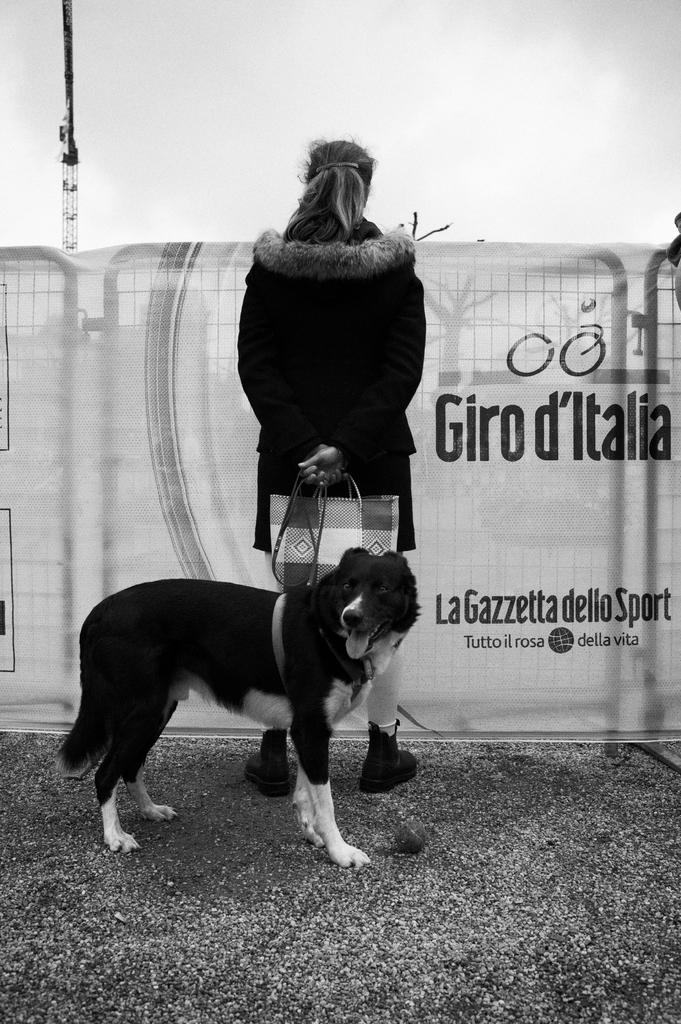Who or what can be seen in the image? There is a woman and a dog in the image. What are the woman and the dog doing in the image? Both the woman and the dog are standing on the ground. What can be seen in the background of the image? There is an advertisement attached to an iron grill, a tower, and the sky visible in the background. How many trees are visible in the image? There are no trees visible in the image. What type of pail is being used by the woman in the image? There is no pail present in the image. 